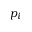Convert formula to latex. <formula><loc_0><loc_0><loc_500><loc_500>p _ { i }</formula> 